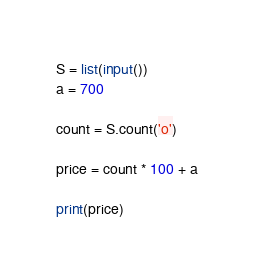<code> <loc_0><loc_0><loc_500><loc_500><_Python_>S = list(input())
a = 700

count = S.count('o')

price = count * 100 + a

print(price)</code> 